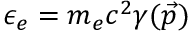<formula> <loc_0><loc_0><loc_500><loc_500>\epsilon _ { e } = m _ { e } c ^ { 2 } \gamma ( \vec { p } )</formula> 